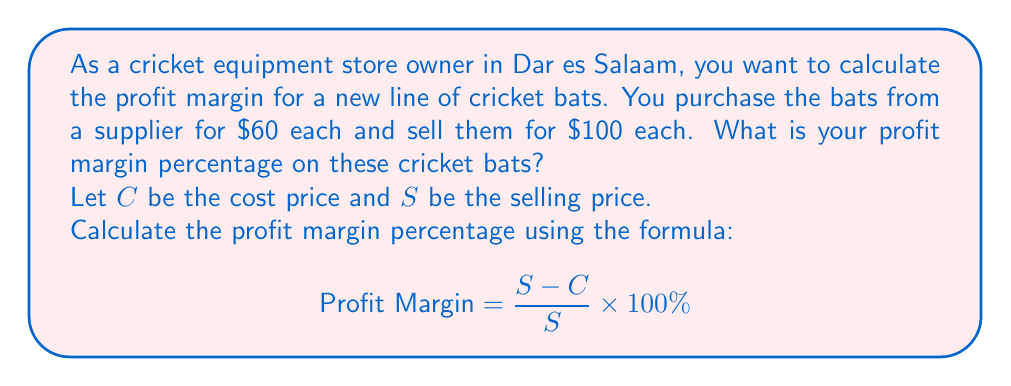Show me your answer to this math problem. To calculate the profit margin percentage, we'll follow these steps:

1. Identify the given values:
   Cost price (C) = $60
   Selling price (S) = $100

2. Calculate the profit (S - C):
   $S - C = 100 - 60 = 40$

3. Apply the profit margin formula:
   $$ \text{Profit Margin} = \frac{S - C}{S} \times 100\% $$
   
   $$ \text{Profit Margin} = \frac{40}{100} \times 100\% $$

4. Simplify the fraction:
   $$ \text{Profit Margin} = 0.4 \times 100\% $$

5. Calculate the final percentage:
   $$ \text{Profit Margin} = 40\% $$

This means that 40% of the selling price is profit.
Answer: The profit margin percentage on the cricket bats is 40%. 